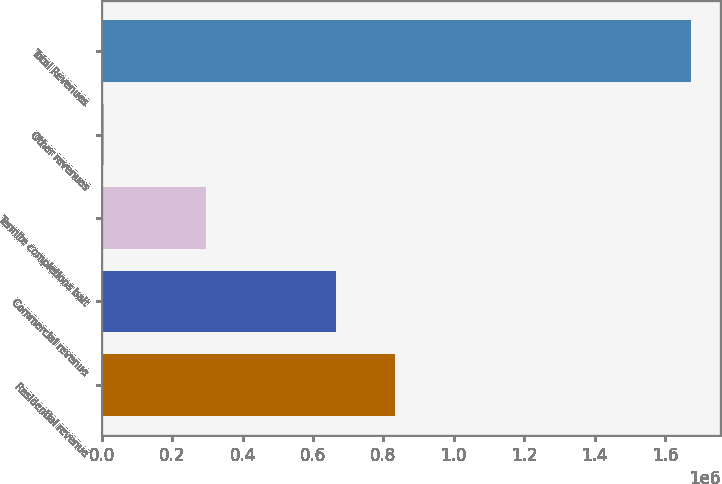Convert chart to OTSL. <chart><loc_0><loc_0><loc_500><loc_500><bar_chart><fcel>Residential revenue<fcel>Commercial revenue<fcel>Termite completions bait<fcel>Other revenues<fcel>Total Revenues<nl><fcel>833252<fcel>666523<fcel>294982<fcel>6665<fcel>1.67396e+06<nl></chart> 